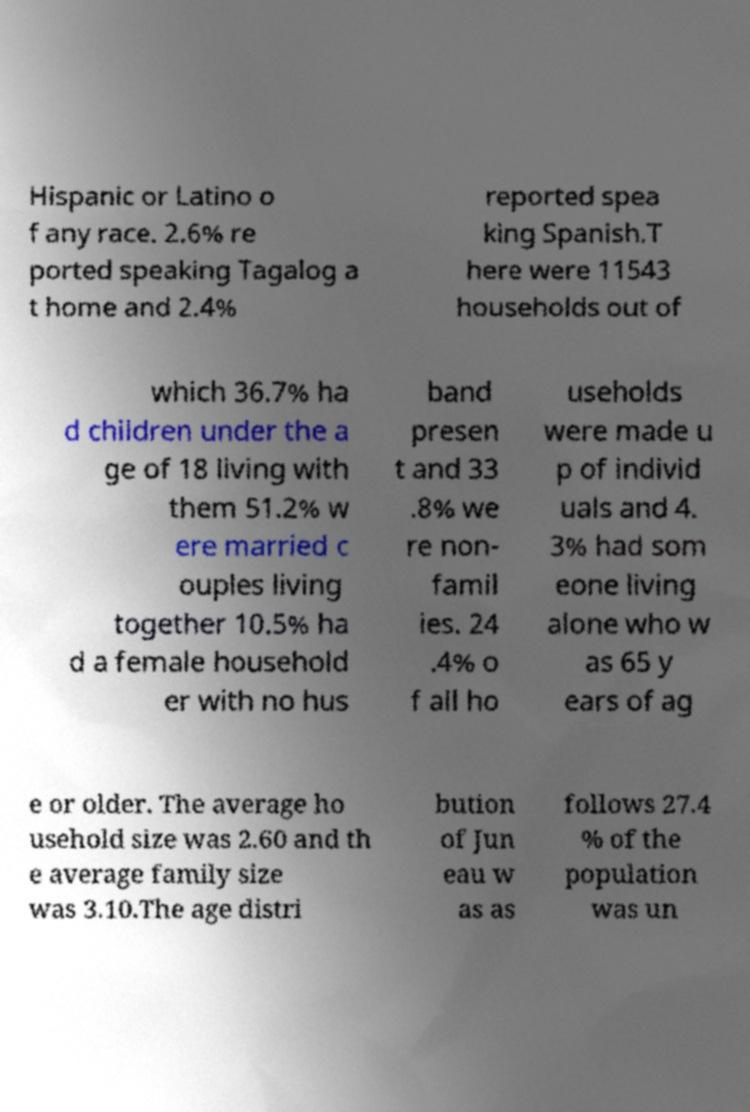Can you accurately transcribe the text from the provided image for me? Hispanic or Latino o f any race. 2.6% re ported speaking Tagalog a t home and 2.4% reported spea king Spanish.T here were 11543 households out of which 36.7% ha d children under the a ge of 18 living with them 51.2% w ere married c ouples living together 10.5% ha d a female household er with no hus band presen t and 33 .8% we re non- famil ies. 24 .4% o f all ho useholds were made u p of individ uals and 4. 3% had som eone living alone who w as 65 y ears of ag e or older. The average ho usehold size was 2.60 and th e average family size was 3.10.The age distri bution of Jun eau w as as follows 27.4 % of the population was un 